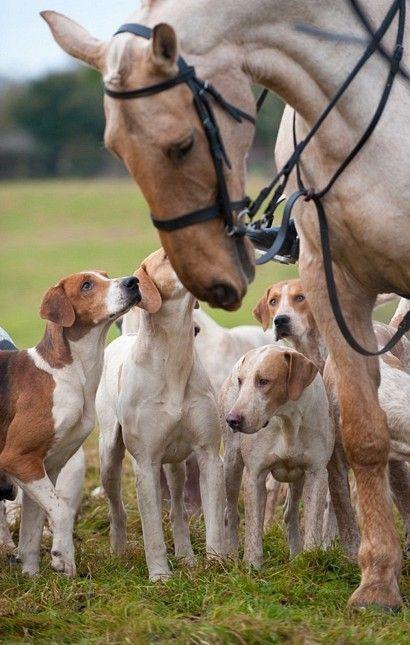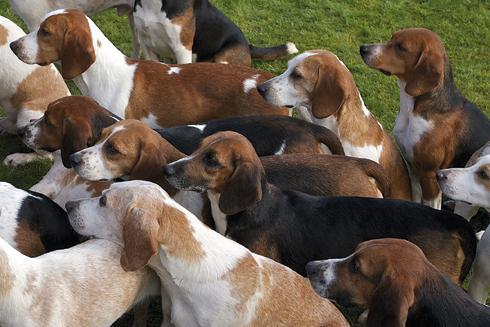The first image is the image on the left, the second image is the image on the right. Given the left and right images, does the statement "A horse is in a grassy area with a group of dogs." hold true? Answer yes or no. Yes. The first image is the image on the left, the second image is the image on the right. Considering the images on both sides, is "At least one horse is present with a group of hounds in one image." valid? Answer yes or no. Yes. 